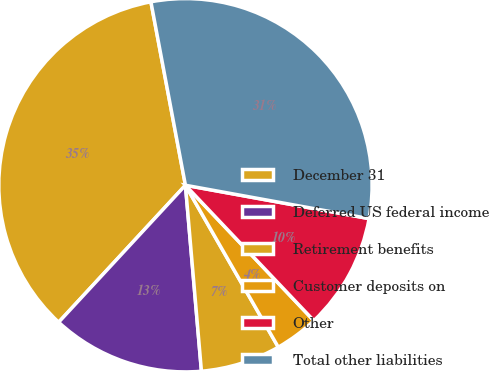Convert chart. <chart><loc_0><loc_0><loc_500><loc_500><pie_chart><fcel>December 31<fcel>Deferred US federal income<fcel>Retirement benefits<fcel>Customer deposits on<fcel>Other<fcel>Total other liabilities<nl><fcel>35.15%<fcel>13.25%<fcel>6.92%<fcel>3.79%<fcel>10.06%<fcel>30.82%<nl></chart> 